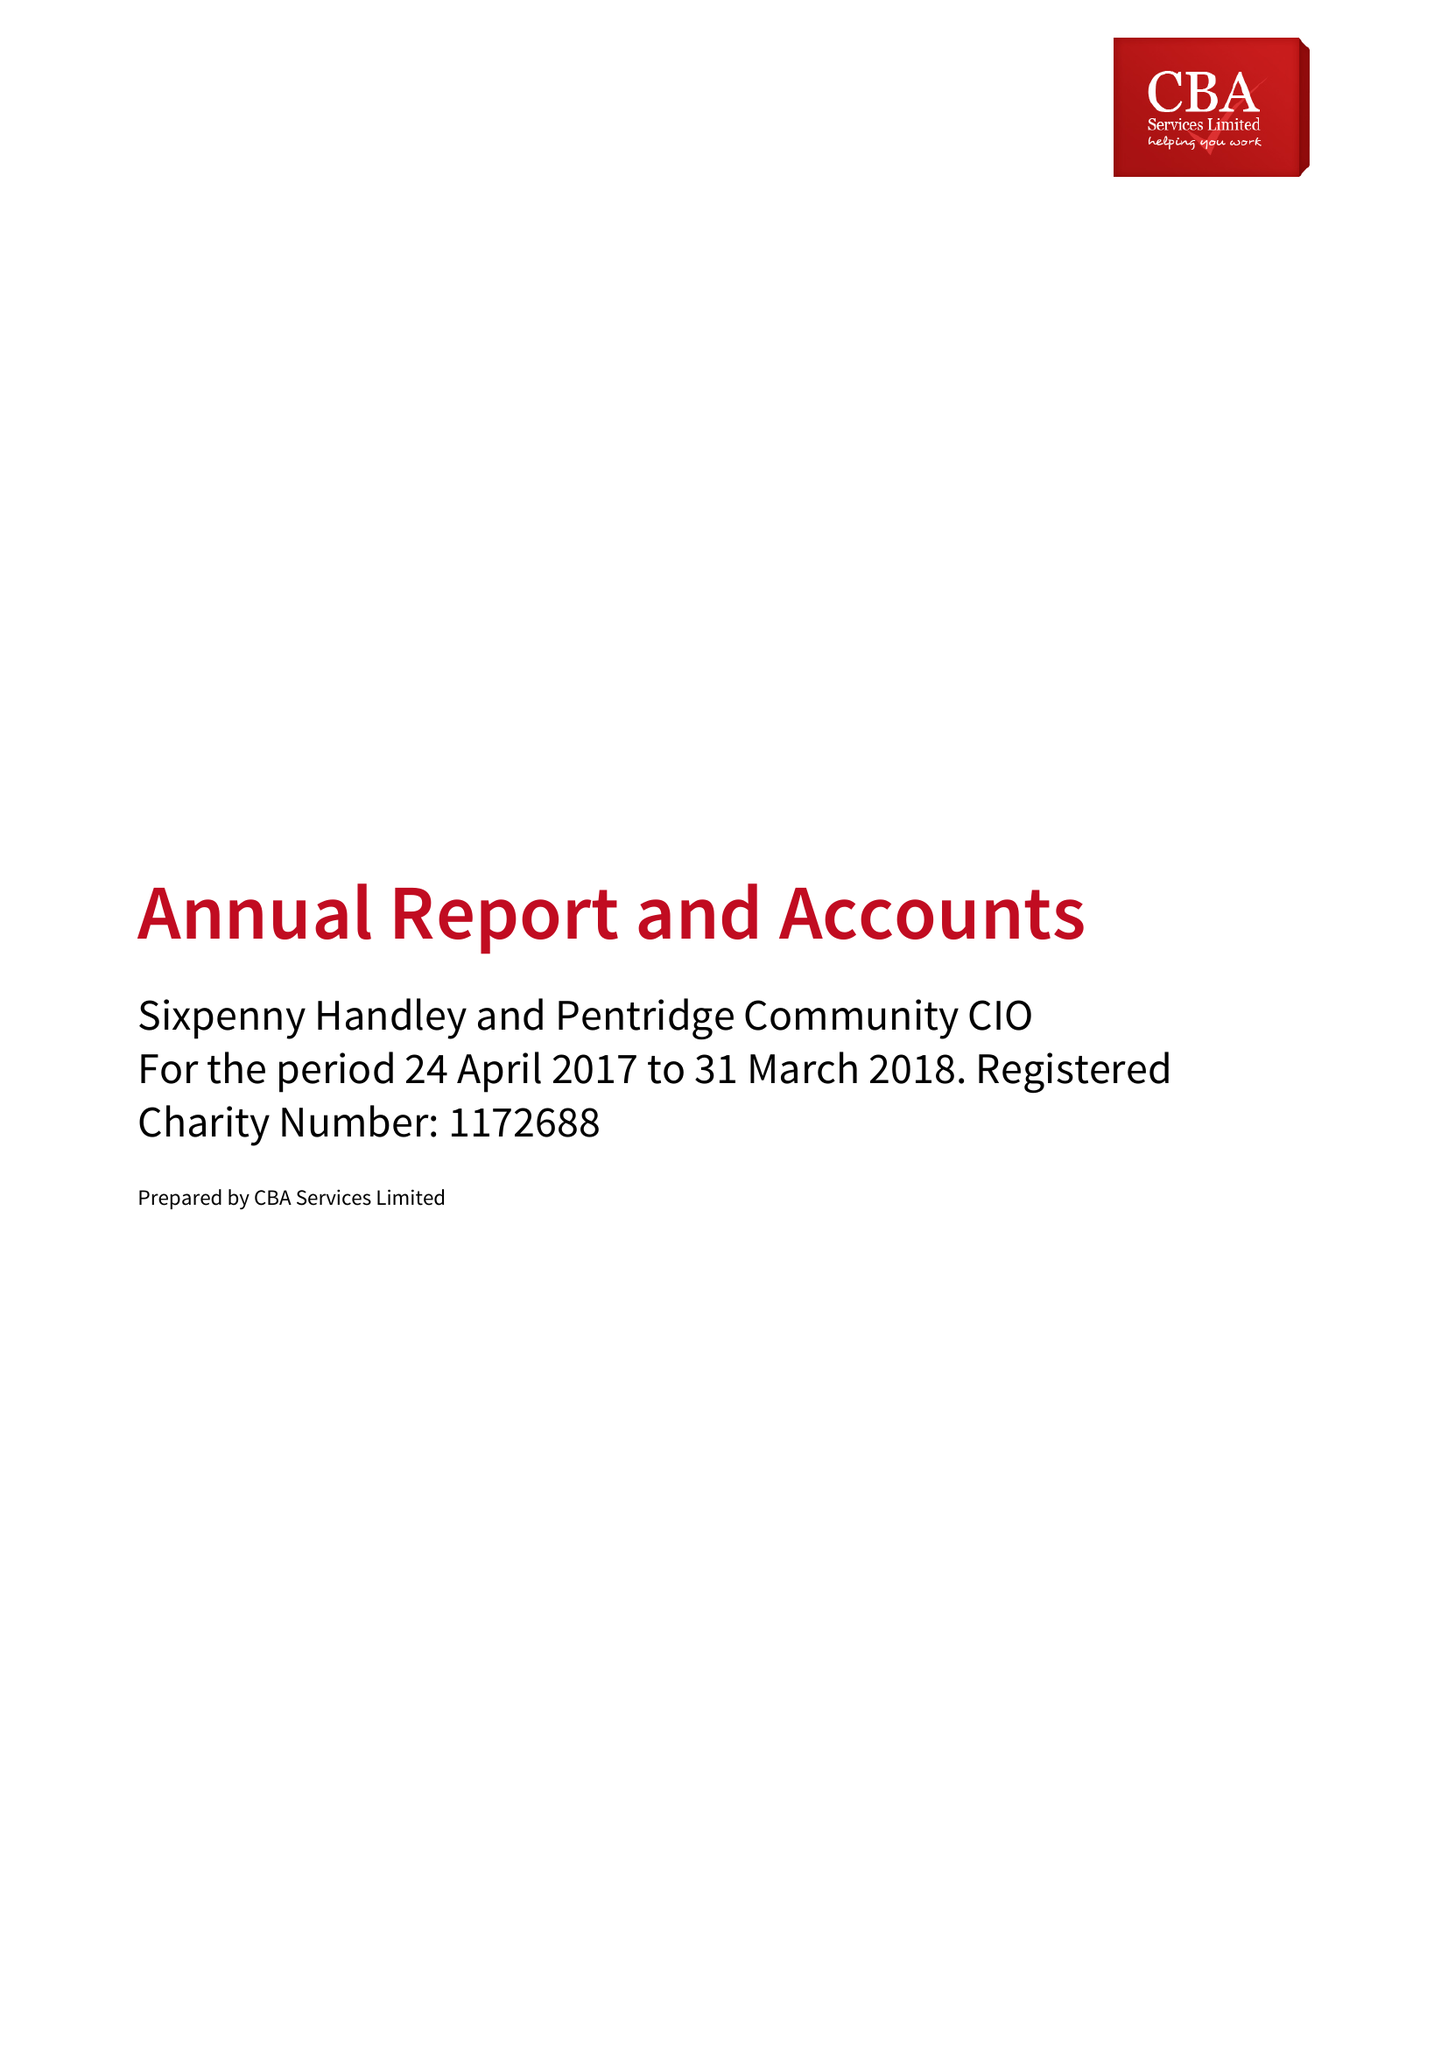What is the value for the report_date?
Answer the question using a single word or phrase. 2018-03-31 